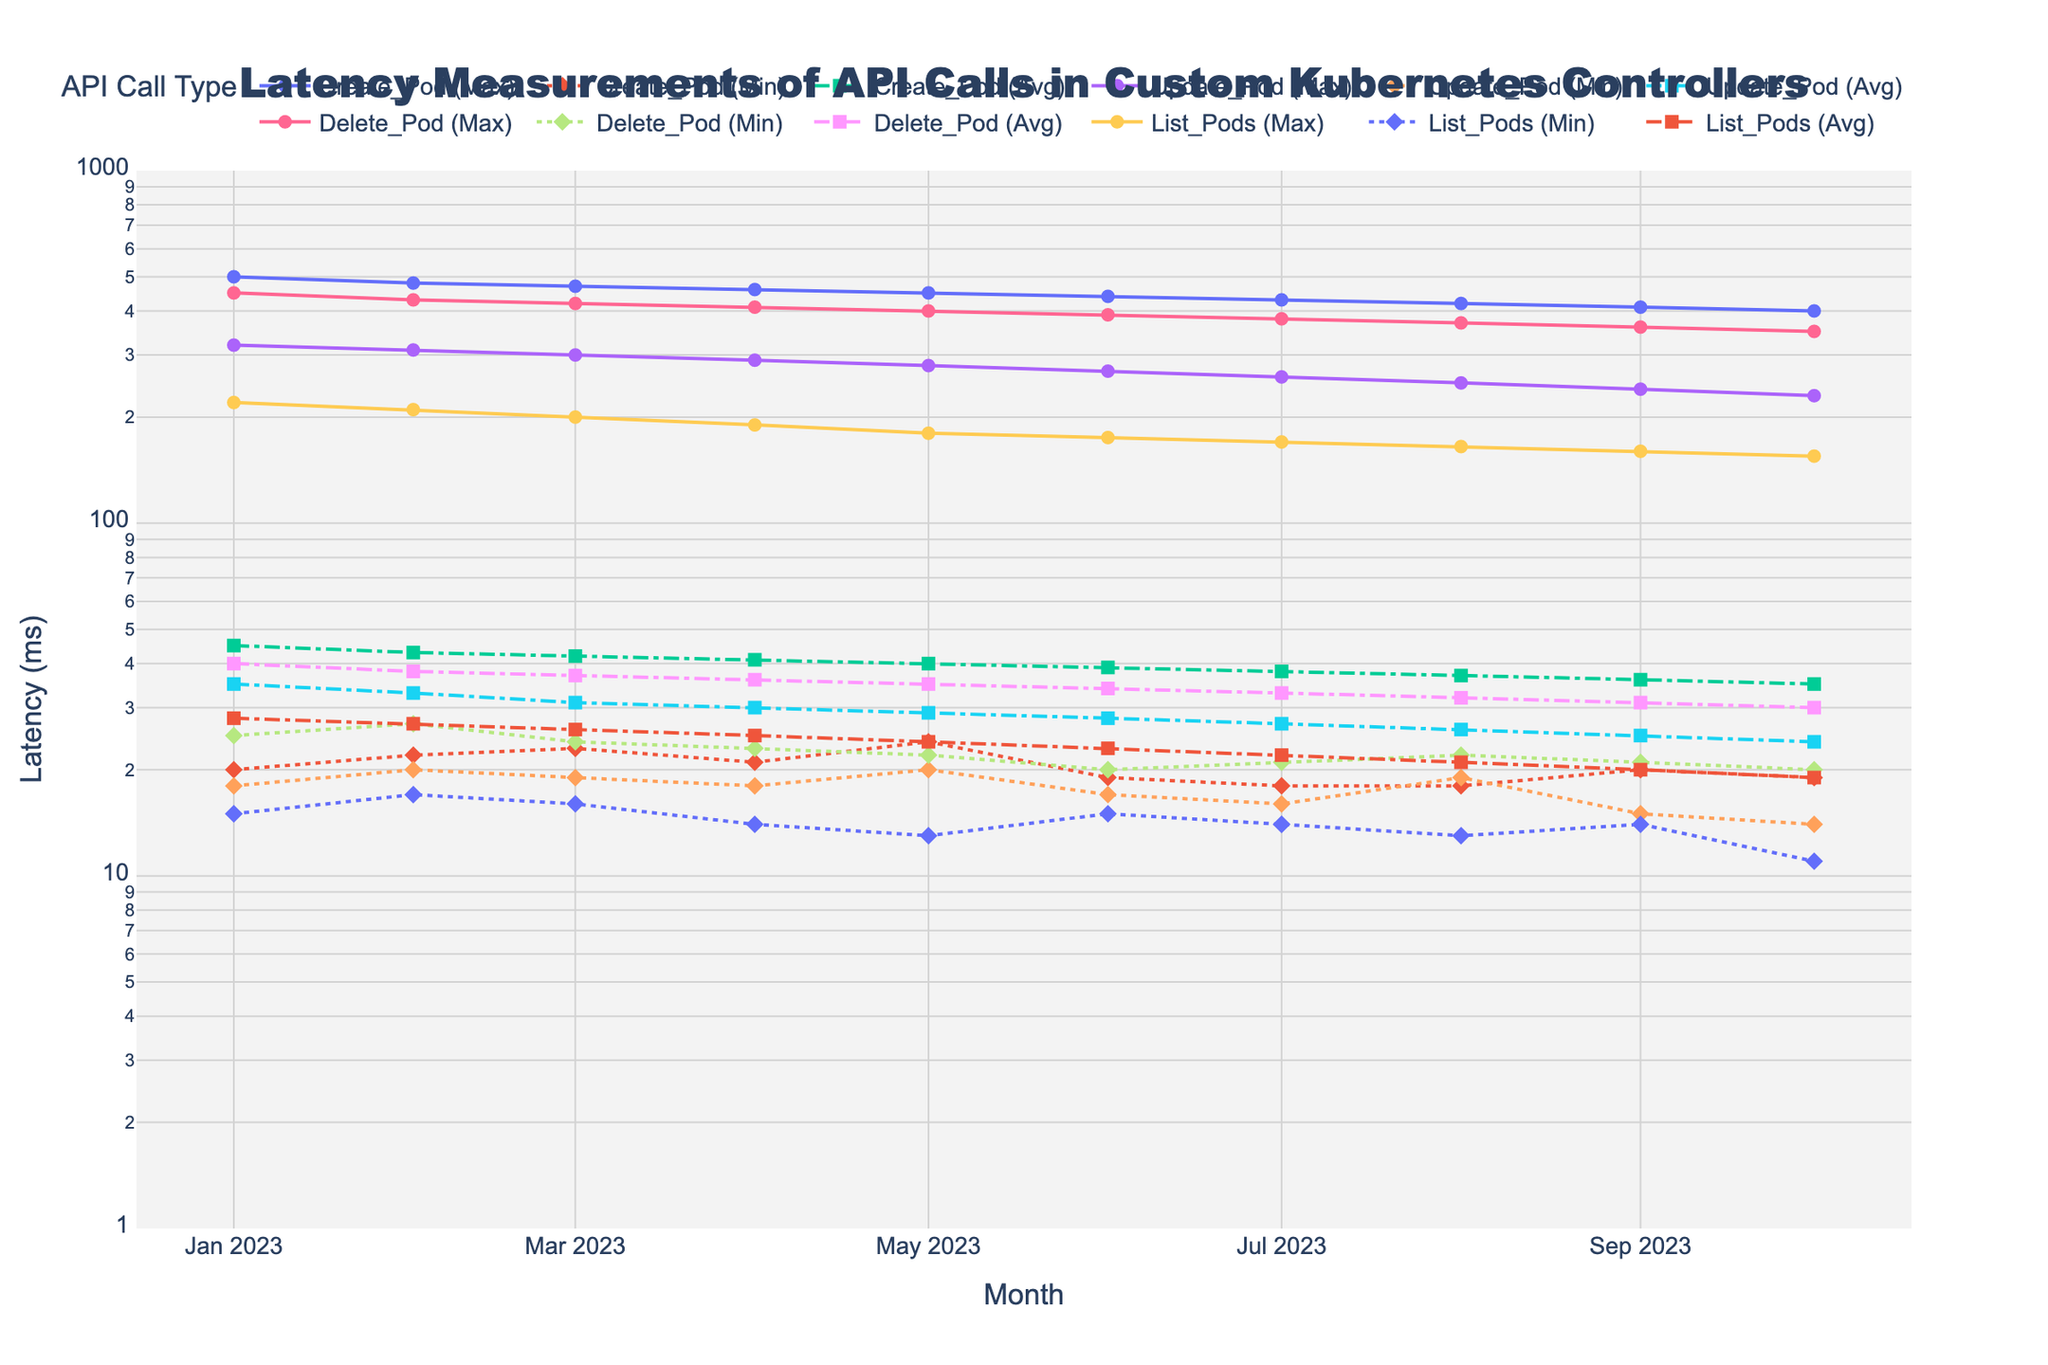What's the title of the plot? The title is usually prominently displayed at the top of the plot. In this case, it should mention "Latency Measurements of API Calls in Custom Kubernetes Controllers," which is provided in the code.
Answer: Latency Measurements of API Calls in Custom Kubernetes Controllers What's the y-axis title of the plot? The y-axis title is provided in the code and should be displayed next to the y-axis of the plot. It indicates what the numbers on the y-axis represent.
Answer: Latency (ms) Over which months is the latency measured? The x-axis of the plot represents the months over which the latency data is plotted. Each tick on the x-axis corresponds to a different month. According to the data provided, the measurements span from January to October 2023.
Answer: January to October 2023 How do the trends in max latency for 'Create_Pod' and 'Delete_Pod' API calls compare over the months? To answer this, observe the lines representing the max latency for both 'Create_Pod' and 'Delete_Pod'. Both should show a trend of their maximum latency decreasing over time, but it’s essential to see which has a steeper decline overall.
Answer: Both have a decreasing trend, with 'Create_Pod' starting higher and declining slightly more consistently Which API call type has the lowest average latency in October 2023? Look for the average latency lines for October 2023 and compare the values. Find the one which is the lowest among the 'Create_Pod', 'Update_Pod', 'Delete_Pod', and 'List_Pods' API call types.
Answer: List_Pods What is the pattern of min latency for 'Update_Pod' compared to 'List_Pods' between April and August 2023? Compare the dotted lines (representing min latency) for 'Update_Pod' and 'List_Pods' between April and August 2023 on the plot. Note the changes in each month for both API call types.
Answer: 'Update_Pod' has a mostly consistent min latency, while 'List_Pods' shows a more significant drop Which month shows the highest max latency for 'Create_Pod'? Observe the line with solid markers representing 'Create_Pod' max latency. Identify the peak point over the months.
Answer: January 2023 How does the average latency of 'Delete_Pod' in May compare to its min latency in the same month? Locate May on the x-axis and find the lines for 'Delete_Pod' average and min latency. Compare their respective values.
Answer: The average latency (35 ms) is significantly higher than the min latency (22 ms) What's the general trend for average latency of 'List_Pods' from January to October 2023? Examine the dashed line representing the average latency of 'List_Pods' across the months. Identify whether it's generally increasing, decreasing, or stable.
Answer: Decreasing How do the min latencies compare between 'Create_Pod' and 'Update_Pod' in June 2023? Find the values for min latency (dotted lines) for both 'Create_Pod' and 'Update_Pod' in June. Compare the two values.
Answer: 'Create_Pod' min latency is 19 ms, and 'Update_Pod' min latency is 17 ms What does the hover information reveal about the max latency of 'Delete_Pod' in February 2023? The hover information is customized to show details on latency values. When hovering over February 2023 for 'Delete_Pod' max latency, it should reveal specifics.
Answer: 430 ms 